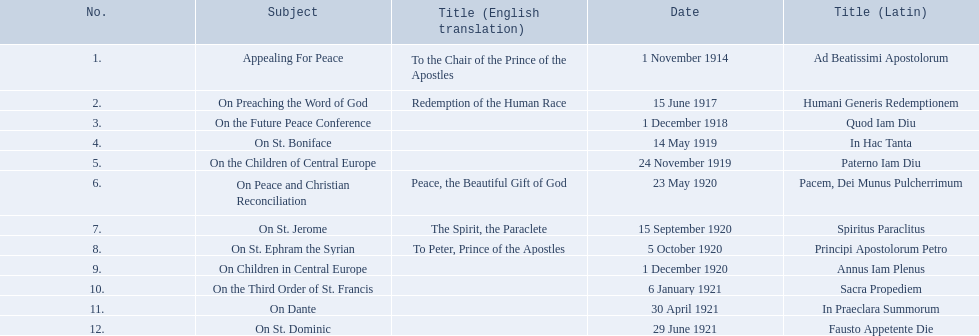What is the dates of the list of encyclicals of pope benedict xv? 1 November 1914, 15 June 1917, 1 December 1918, 14 May 1919, 24 November 1919, 23 May 1920, 15 September 1920, 5 October 1920, 1 December 1920, 6 January 1921, 30 April 1921, 29 June 1921. Of these dates, which subject was on 23 may 1920? On Peace and Christian Reconciliation. 